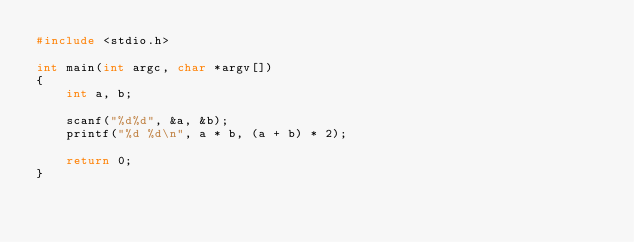<code> <loc_0><loc_0><loc_500><loc_500><_C_>#include <stdio.h>

int main(int argc, char *argv[])
{
    int a, b;

    scanf("%d%d", &a, &b);
    printf("%d %d\n", a * b, (a + b) * 2);
    
    return 0;
}
</code> 